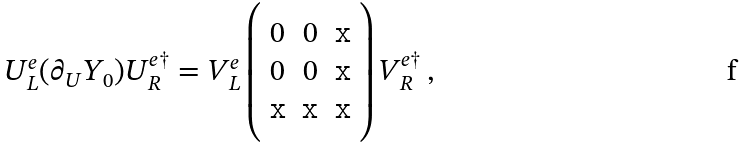Convert formula to latex. <formula><loc_0><loc_0><loc_500><loc_500>U _ { L } ^ { e } ( \partial _ { U } Y _ { 0 } ) U _ { R } ^ { e \dagger } = V _ { L } ^ { e } \left ( \begin{array} { c c c } 0 & 0 & { \tt x } \\ 0 & 0 & { \tt x } \\ { \tt x } & { \tt x } & { \tt x } \end{array} \right ) V _ { R } ^ { e \dagger } \, ,</formula> 